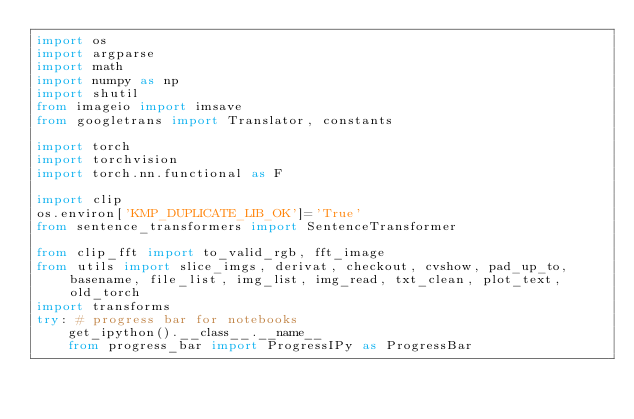Convert code to text. <code><loc_0><loc_0><loc_500><loc_500><_Python_>import os
import argparse
import math
import numpy as np
import shutil
from imageio import imsave
from googletrans import Translator, constants

import torch
import torchvision
import torch.nn.functional as F

import clip
os.environ['KMP_DUPLICATE_LIB_OK']='True'
from sentence_transformers import SentenceTransformer

from clip_fft import to_valid_rgb, fft_image
from utils import slice_imgs, derivat, checkout, cvshow, pad_up_to, basename, file_list, img_list, img_read, txt_clean, plot_text, old_torch
import transforms
try: # progress bar for notebooks 
    get_ipython().__class__.__name__
    from progress_bar import ProgressIPy as ProgressBar</code> 